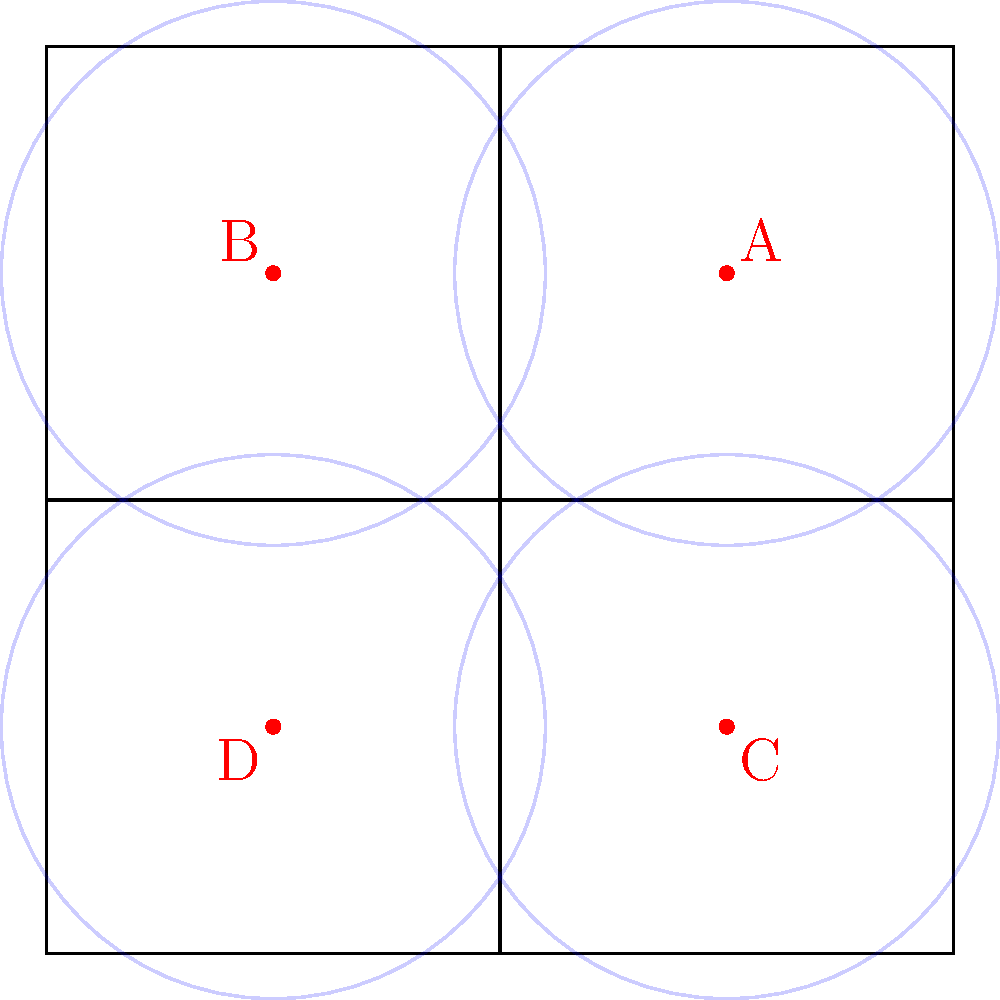Based on the diagram of a busy urban intersection with four surveillance cameras (A, B, C, and D) positioned at the corners, which camera placement would be most crucial for monitoring potential criminal activities while minimizing blind spots? Consider factors such as traffic flow and pedestrian movement. To determine the most crucial camera placement, we need to analyze the intersection layout and consider various factors:

1. Traffic flow: In a typical intersection, the heaviest traffic flow is often along the main road, which is usually the road with more lanes or higher speed limits.

2. Pedestrian movement: Crosswalks and sidewalks are areas where pedestrians are most vulnerable and where criminal activities might occur.

3. Blind spots: The corners of buildings or large objects can create blind spots, which criminals might exploit.

4. Coverage overlap: Ideally, cameras should have overlapping fields of view to ensure complete coverage.

5. Entry and exit points: Monitoring vehicles entering and leaving the intersection is crucial for tracking suspects.

Analyzing the diagram:

1. All four cameras (A, B, C, and D) are placed at the corners of the intersection, providing a good overall view.

2. The blue circles represent the approximate coverage areas of each camera.

3. Cameras A and C cover the northeast-southwest diagonal, while B and D cover the northwest-southeast diagonal.

4. The center of the intersection is covered by all four cameras, ensuring maximum surveillance of the most critical area.

5. Each camera covers two approaching lanes of traffic and two departing lanes.

Given these observations, the most crucial camera placement would be either A or C, as they likely cover the main road (assuming the northeast-southwest direction is the primary traffic flow). Between A and C, camera A would be slightly more important because:

1. It covers the approach of vehicles from the busier direction (assuming northeast is the direction of incoming traffic to the city center).

2. It likely has a better view of pedestrians crossing the street in the foreground.

3. It can monitor vehicles leaving the intersection in multiple directions.

4. Its position allows for better facial recognition of pedestrians and drivers due to the angle of approach.

While all cameras are important for complete coverage, camera A provides the most critical viewpoint for monitoring potential criminal activities and minimizing blind spots in this urban intersection scenario.
Answer: Camera A 